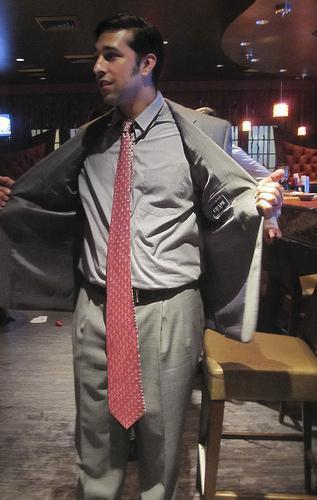How many pendant lights are hanging?
Give a very brief answer. 3. 